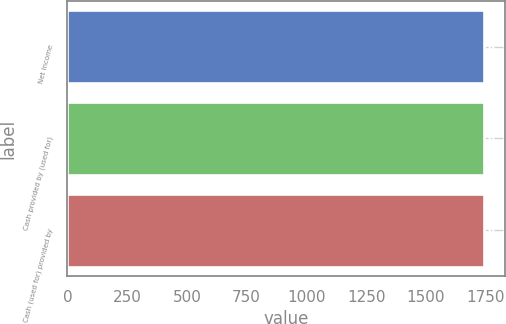Convert chart to OTSL. <chart><loc_0><loc_0><loc_500><loc_500><bar_chart><fcel>Net income<fcel>Cash provided by (used for)<fcel>Cash (used for) provided by<nl><fcel>1745<fcel>1745.1<fcel>1745.2<nl></chart> 